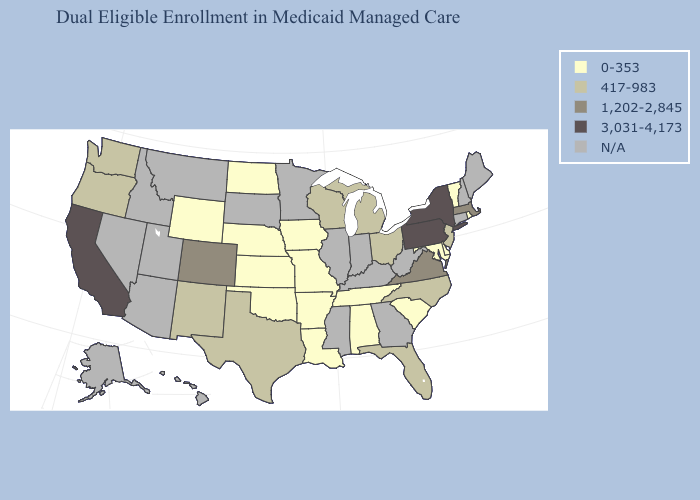Does the map have missing data?
Concise answer only. Yes. Among the states that border Ohio , does Pennsylvania have the highest value?
Write a very short answer. Yes. Which states hav the highest value in the South?
Write a very short answer. Virginia. Among the states that border Maryland , which have the highest value?
Answer briefly. Pennsylvania. What is the lowest value in the Northeast?
Give a very brief answer. 0-353. Which states have the lowest value in the USA?
Be succinct. Alabama, Arkansas, Delaware, Iowa, Kansas, Louisiana, Maryland, Missouri, Nebraska, North Dakota, Oklahoma, Rhode Island, South Carolina, Tennessee, Vermont, Wyoming. What is the value of Vermont?
Give a very brief answer. 0-353. Among the states that border New Jersey , does Pennsylvania have the lowest value?
Concise answer only. No. What is the highest value in the West ?
Write a very short answer. 3,031-4,173. Does Ohio have the highest value in the MidWest?
Quick response, please. Yes. What is the highest value in states that border Vermont?
Write a very short answer. 3,031-4,173. How many symbols are there in the legend?
Short answer required. 5. 